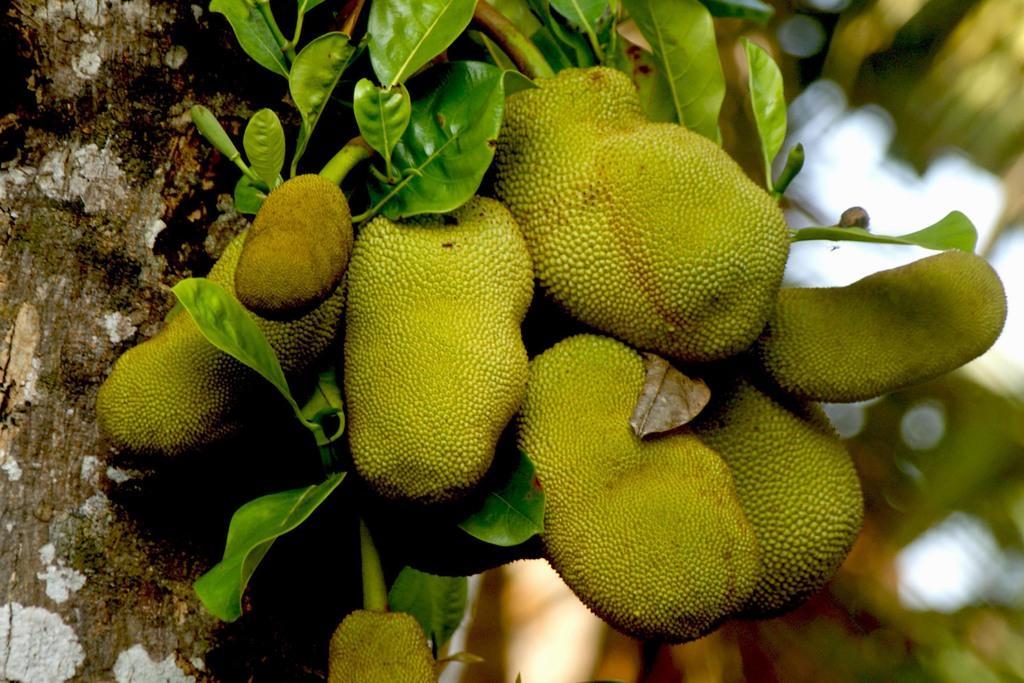Could you give a brief overview of what you see in this image? In this picture we can observe jackfruits which are in green color. We can observe a tree on the left side. The background is completely blurred. 